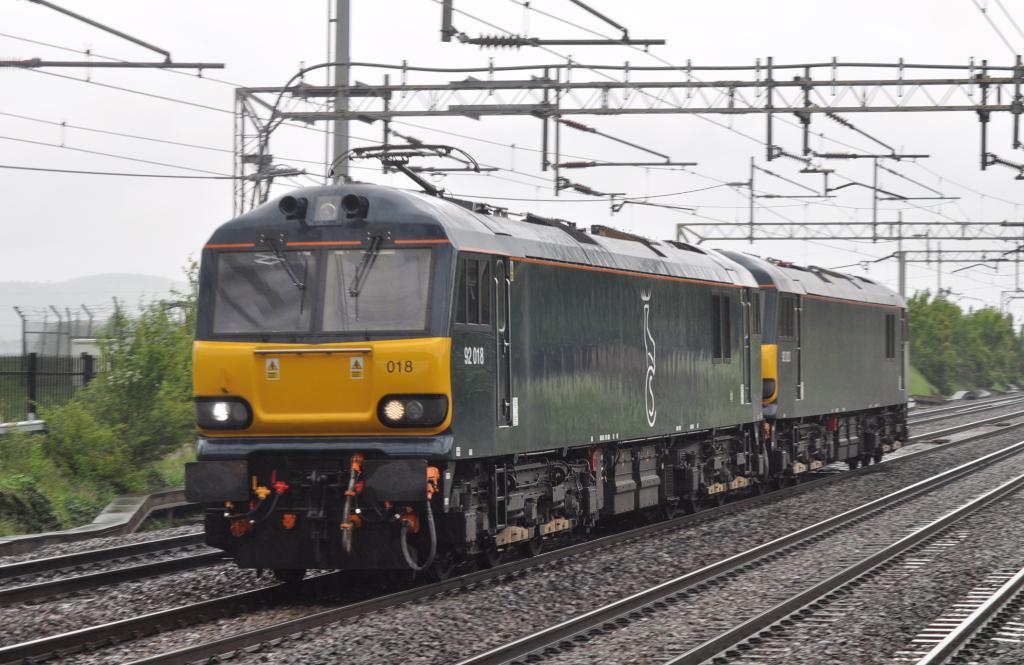What is the number on the front right of the train?
Make the answer very short. 018. 